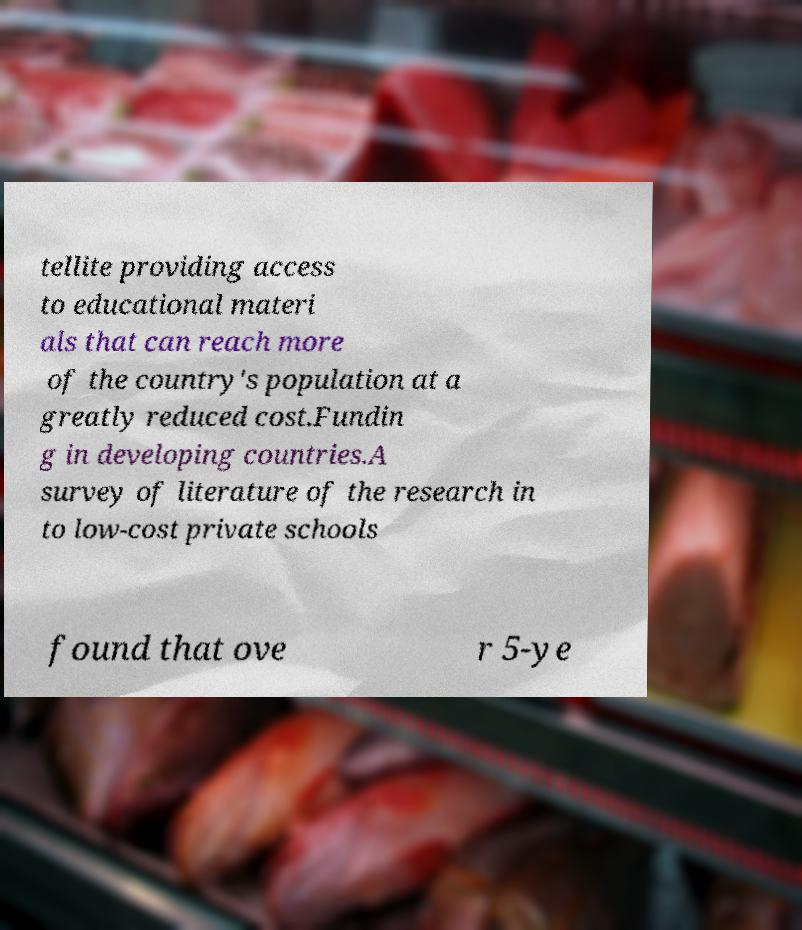Please read and relay the text visible in this image. What does it say? tellite providing access to educational materi als that can reach more of the country's population at a greatly reduced cost.Fundin g in developing countries.A survey of literature of the research in to low-cost private schools found that ove r 5-ye 